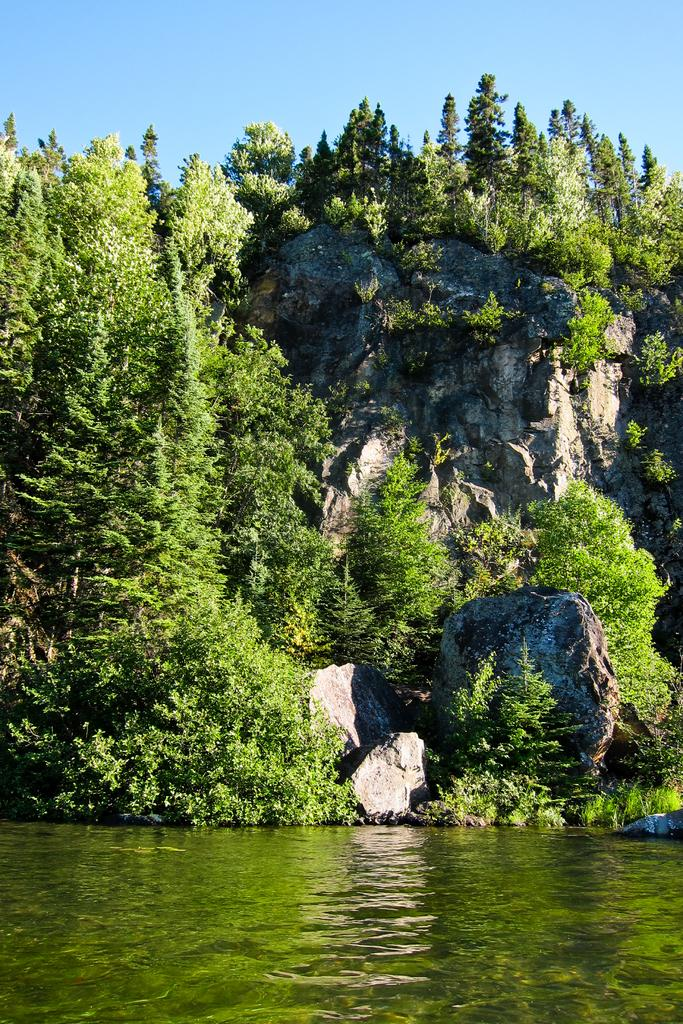What is the primary element visible in the image? There is water in the image. What type of natural vegetation can be seen in the image? There are trees in the image. What other objects are present in the image? There are rocks in the image. What can be seen in the background of the image? The sky is visible in the background of the image. What type of jam is being spread on the rocks in the image? There is no jam present in the image; it features water, trees, rocks, and the sky. 